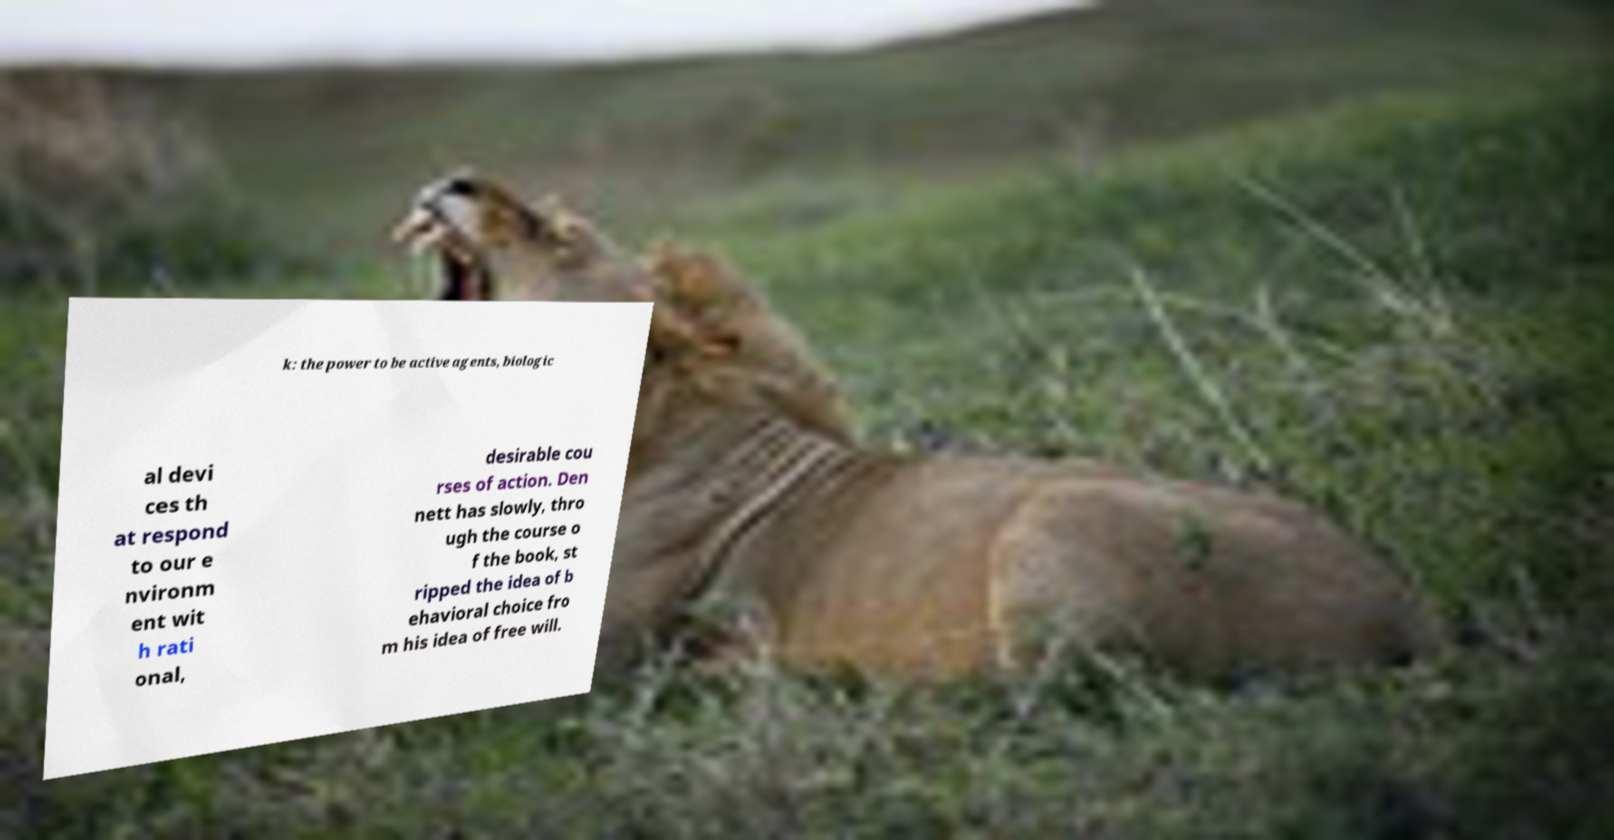Please read and relay the text visible in this image. What does it say? k: the power to be active agents, biologic al devi ces th at respond to our e nvironm ent wit h rati onal, desirable cou rses of action. Den nett has slowly, thro ugh the course o f the book, st ripped the idea of b ehavioral choice fro m his idea of free will. 